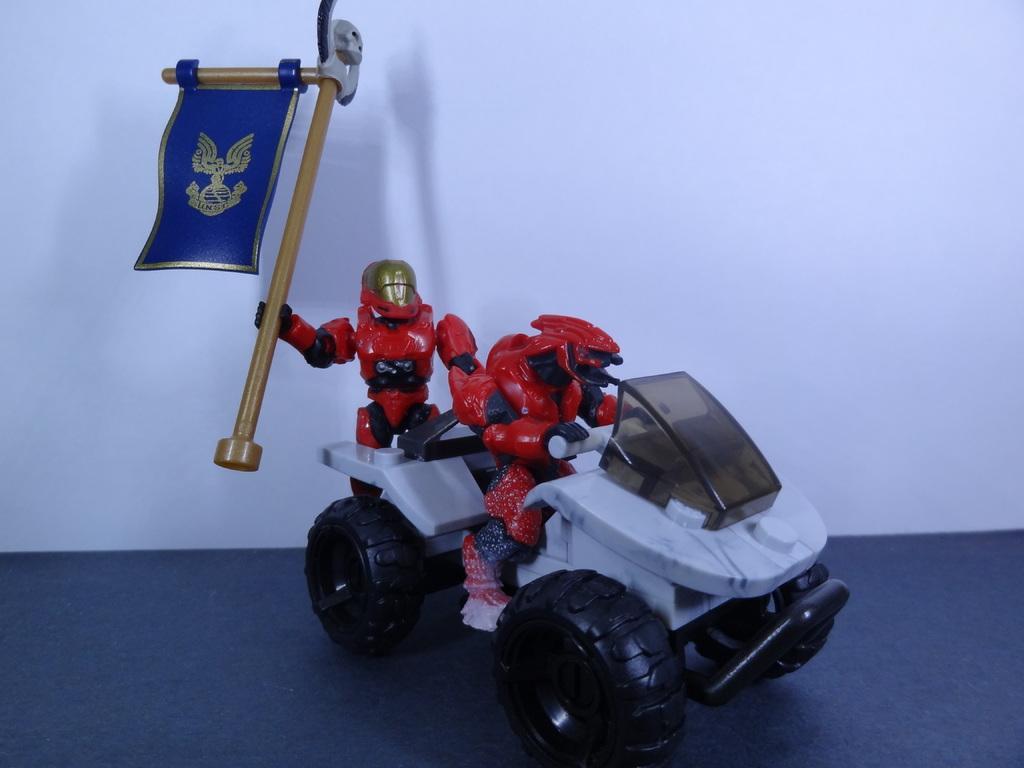Please provide a concise description of this image. In this image we can see a toy on a platform. There is a white background. 